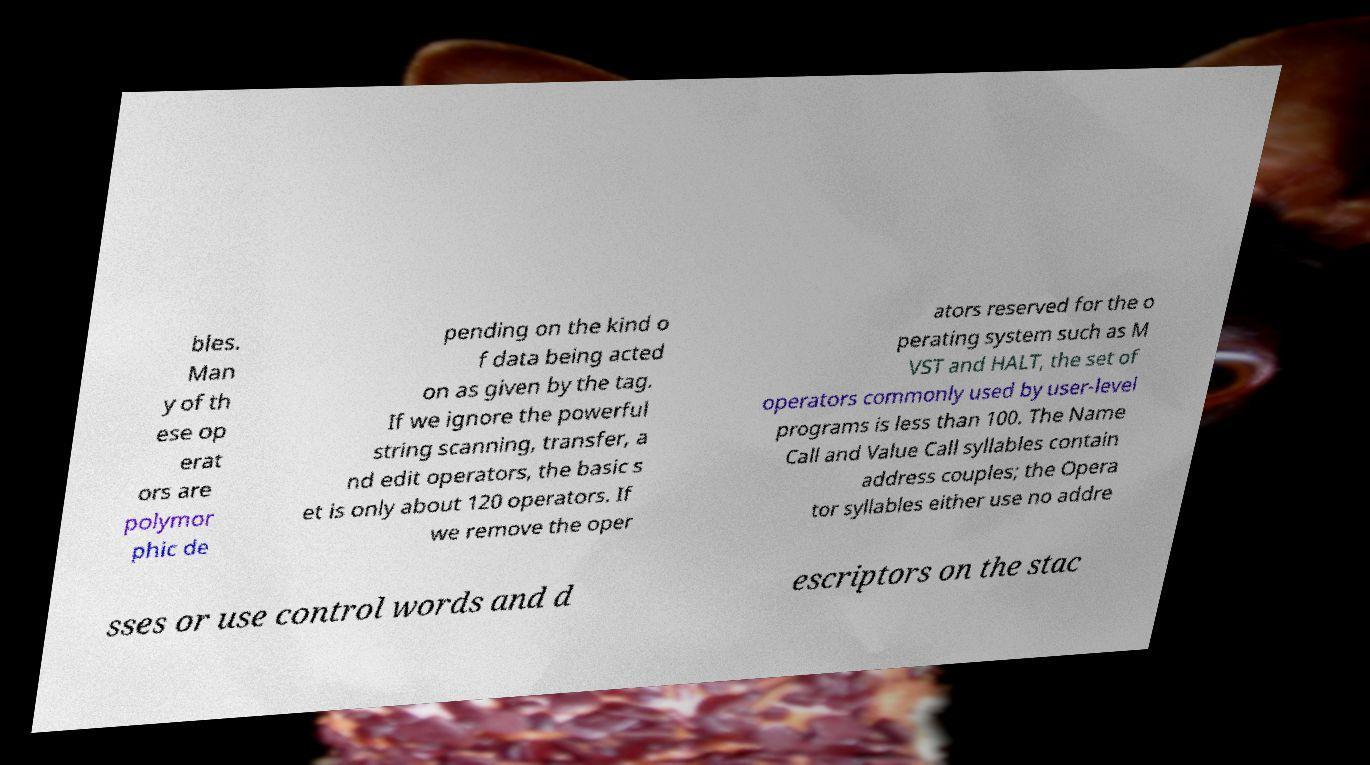Can you read and provide the text displayed in the image?This photo seems to have some interesting text. Can you extract and type it out for me? bles. Man y of th ese op erat ors are polymor phic de pending on the kind o f data being acted on as given by the tag. If we ignore the powerful string scanning, transfer, a nd edit operators, the basic s et is only about 120 operators. If we remove the oper ators reserved for the o perating system such as M VST and HALT, the set of operators commonly used by user-level programs is less than 100. The Name Call and Value Call syllables contain address couples; the Opera tor syllables either use no addre sses or use control words and d escriptors on the stac 